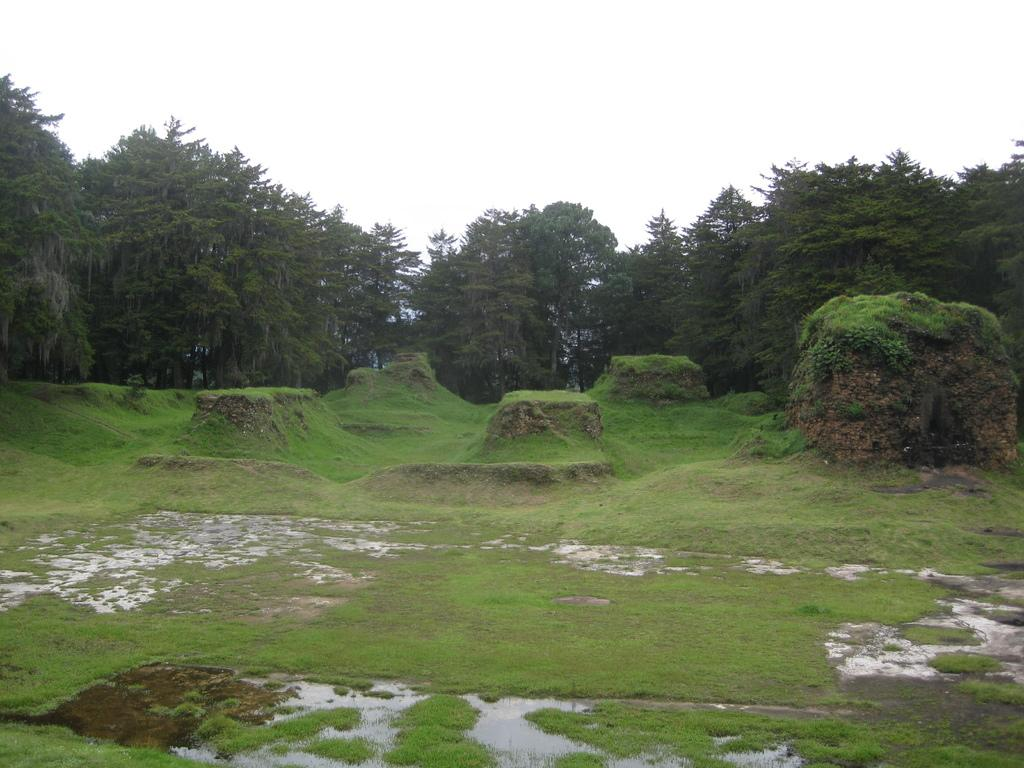Where was the picture taken? The picture was clicked outside. What can be seen in the foreground of the image? There is green grass and other objects in the foreground. What type of vegetation is visible in the image? There are trees visible in the image. What part of the natural environment is visible in the background? The sky is visible in the background. What is the price of the stranger walking through the grass in the image? There is no stranger walking through the grass in the image, and therefore no price can be associated with such an event. 